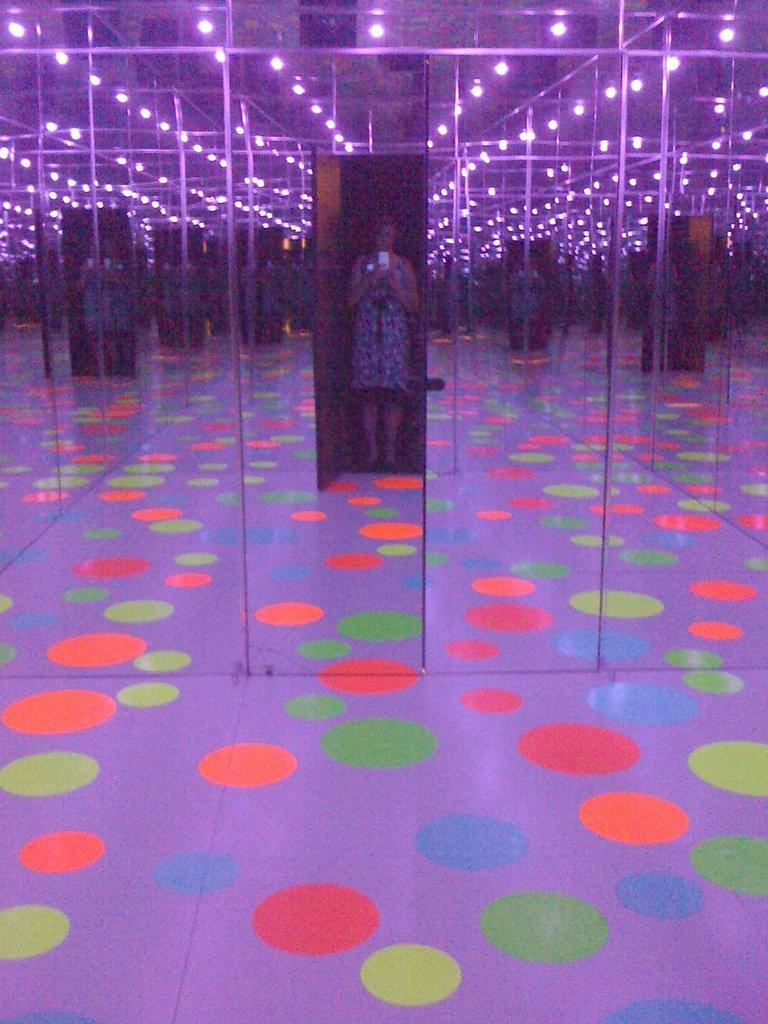What is the person in the image doing? The person is standing in the image. What object is the person holding in her hand? The person is holding a mobile phone in her hand. What pattern can be seen on the ground in the image? There are colorful polka dots on the ground. What type of reflective surfaces are present in the image? There are mirrors in the image. What type of work is the person doing in the image? The provided facts do not mention any work being done by the person in the image. --- Facts: 1. There is a person sitting on a chair in the image. 2. The person is holding a book in her hand. 3. There is a table next to the chair. 4. There is a lamp on the table. 5. The room has a wooden floor. Absurd Topics: dance, ocean, animal Conversation: What is the person in the image doing? The person is sitting on a chair in the image. What object is the person holding in her hand? The person is holding a book in her hand. What piece of furniture is next to the chair? There is a table next to the chair. What type of lighting is present on the table? There is a lamp on the table. What type of flooring can be seen in the room? The room has a wooden floor. Reasoning: Let's think step by step in order to produce the conversation. We start by identifying the main subject in the image, which is the person sitting on a chair. Then, we expand the conversation to include other details about the person, such as the object she is holding (a book). Next, we describe the furniture and objects in the room (a table and a lamp), and finally, we mention the type of flooring (wooden). Absurd Question/Answer: Can you see any ocean waves in the image? No, there is no ocean or waves present in the image. 